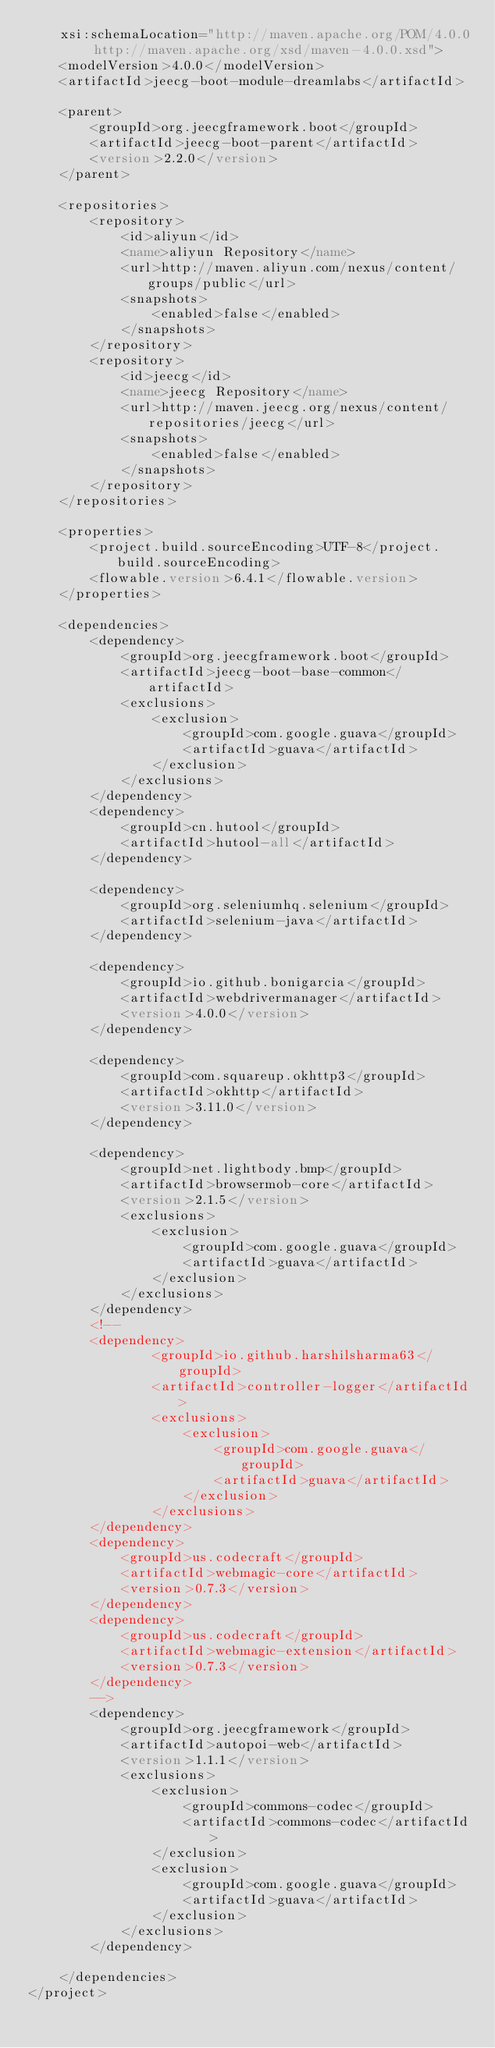Convert code to text. <code><loc_0><loc_0><loc_500><loc_500><_XML_>	xsi:schemaLocation="http://maven.apache.org/POM/4.0.0 http://maven.apache.org/xsd/maven-4.0.0.xsd">
	<modelVersion>4.0.0</modelVersion>
	<artifactId>jeecg-boot-module-dreamlabs</artifactId>

	<parent>
		<groupId>org.jeecgframework.boot</groupId>
		<artifactId>jeecg-boot-parent</artifactId>
		<version>2.2.0</version>
	</parent>

	<repositories>
		<repository>
			<id>aliyun</id>
			<name>aliyun Repository</name>
			<url>http://maven.aliyun.com/nexus/content/groups/public</url>
			<snapshots>
				<enabled>false</enabled>
			</snapshots>
		</repository>
		<repository>
			<id>jeecg</id>
			<name>jeecg Repository</name>
			<url>http://maven.jeecg.org/nexus/content/repositories/jeecg</url>
			<snapshots>
				<enabled>false</enabled>
			</snapshots>
		</repository>
	</repositories>

	<properties>
		<project.build.sourceEncoding>UTF-8</project.build.sourceEncoding>
		<flowable.version>6.4.1</flowable.version>
	</properties>

	<dependencies>
		<dependency>
			<groupId>org.jeecgframework.boot</groupId>
			<artifactId>jeecg-boot-base-common</artifactId>
			<exclusions>
				<exclusion>
					<groupId>com.google.guava</groupId>
					<artifactId>guava</artifactId>
				</exclusion>
			</exclusions>
		</dependency>
		<dependency>
			<groupId>cn.hutool</groupId>
			<artifactId>hutool-all</artifactId>
		</dependency>

		<dependency>
			<groupId>org.seleniumhq.selenium</groupId>
			<artifactId>selenium-java</artifactId>
		</dependency>

		<dependency>
			<groupId>io.github.bonigarcia</groupId>
			<artifactId>webdrivermanager</artifactId>
			<version>4.0.0</version>
		</dependency>

		<dependency>
			<groupId>com.squareup.okhttp3</groupId>
			<artifactId>okhttp</artifactId>
			<version>3.11.0</version>
		</dependency>

		<dependency>
			<groupId>net.lightbody.bmp</groupId>
			<artifactId>browsermob-core</artifactId>
			<version>2.1.5</version>
			<exclusions>
				<exclusion>
					<groupId>com.google.guava</groupId>
					<artifactId>guava</artifactId>
				</exclusion>
			</exclusions>
		</dependency>
		<!-- 
		<dependency>
			    <groupId>io.github.harshilsharma63</groupId>
			    <artifactId>controller-logger</artifactId>
			    <exclusions>
			    	<exclusion>
			    		<groupId>com.google.guava</groupId>
			    		<artifactId>guava</artifactId>
			    	</exclusion>
			    </exclusions>
		</dependency>
		<dependency>
			<groupId>us.codecraft</groupId>
			<artifactId>webmagic-core</artifactId>
			<version>0.7.3</version>
		</dependency>
		<dependency>
			<groupId>us.codecraft</groupId>
			<artifactId>webmagic-extension</artifactId>
			<version>0.7.3</version>
		</dependency> 
		-->
		<dependency>
			<groupId>org.jeecgframework</groupId>
			<artifactId>autopoi-web</artifactId>
			<version>1.1.1</version>
			<exclusions>
				<exclusion>
					<groupId>commons-codec</groupId>
					<artifactId>commons-codec</artifactId>
				</exclusion>
				<exclusion>
					<groupId>com.google.guava</groupId>
					<artifactId>guava</artifactId>
				</exclusion>
			</exclusions>
		</dependency>
	
	</dependencies>
</project></code> 